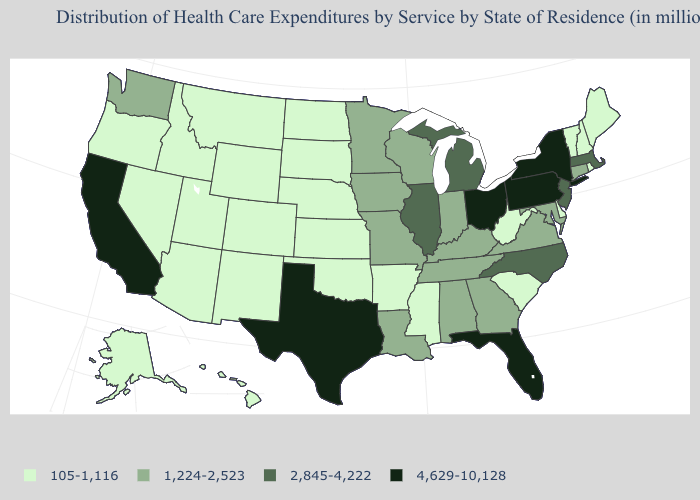What is the value of California?
Quick response, please. 4,629-10,128. Does the first symbol in the legend represent the smallest category?
Answer briefly. Yes. What is the highest value in states that border Oklahoma?
Answer briefly. 4,629-10,128. Which states have the lowest value in the USA?
Be succinct. Alaska, Arizona, Arkansas, Colorado, Delaware, Hawaii, Idaho, Kansas, Maine, Mississippi, Montana, Nebraska, Nevada, New Hampshire, New Mexico, North Dakota, Oklahoma, Oregon, Rhode Island, South Carolina, South Dakota, Utah, Vermont, West Virginia, Wyoming. What is the value of Minnesota?
Answer briefly. 1,224-2,523. What is the value of Massachusetts?
Keep it brief. 2,845-4,222. What is the lowest value in states that border Nevada?
Give a very brief answer. 105-1,116. Name the states that have a value in the range 4,629-10,128?
Short answer required. California, Florida, New York, Ohio, Pennsylvania, Texas. Name the states that have a value in the range 1,224-2,523?
Concise answer only. Alabama, Connecticut, Georgia, Indiana, Iowa, Kentucky, Louisiana, Maryland, Minnesota, Missouri, Tennessee, Virginia, Washington, Wisconsin. What is the value of Maryland?
Quick response, please. 1,224-2,523. Name the states that have a value in the range 105-1,116?
Be succinct. Alaska, Arizona, Arkansas, Colorado, Delaware, Hawaii, Idaho, Kansas, Maine, Mississippi, Montana, Nebraska, Nevada, New Hampshire, New Mexico, North Dakota, Oklahoma, Oregon, Rhode Island, South Carolina, South Dakota, Utah, Vermont, West Virginia, Wyoming. What is the lowest value in the USA?
Give a very brief answer. 105-1,116. Which states have the lowest value in the South?
Short answer required. Arkansas, Delaware, Mississippi, Oklahoma, South Carolina, West Virginia. What is the highest value in states that border Arizona?
Concise answer only. 4,629-10,128. What is the value of Idaho?
Concise answer only. 105-1,116. 